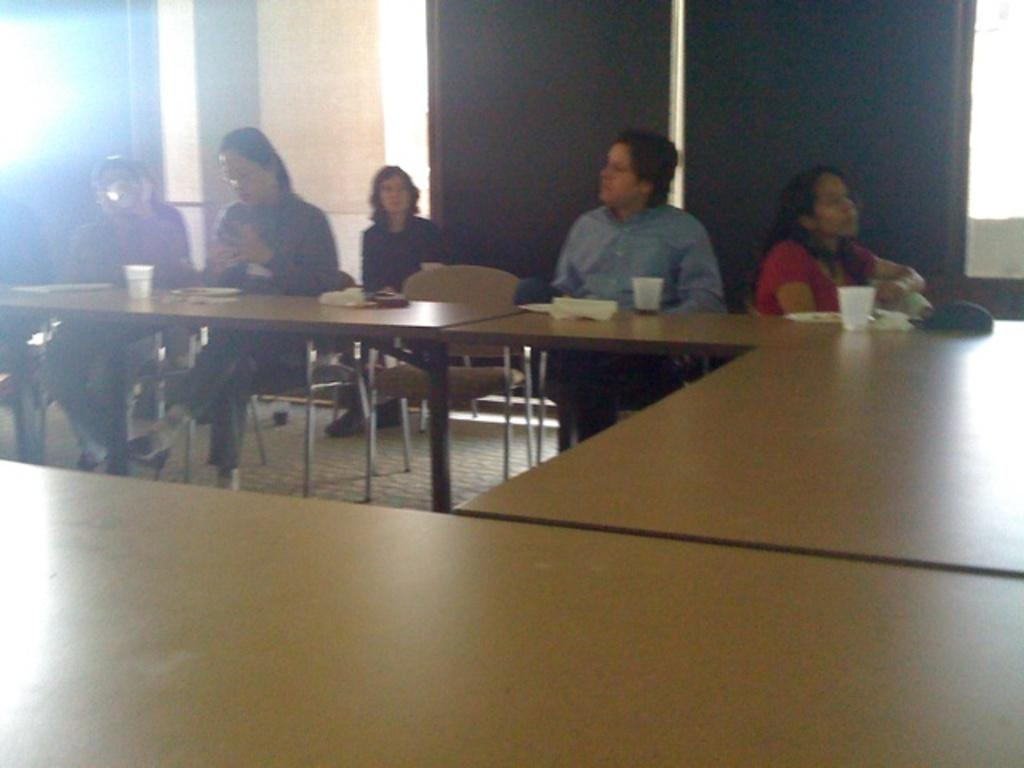How many people are present in the image? There are five people in the image. What are the people doing in the image? The people are sitting on chairs. Where are the chairs located in relation to the desk? The chairs are in front of a desk. What items can be seen on the desk? There are glasses and tissues on the desk. What type of pies are being served on the desk in the image? There are no pies present in the image; only glasses and tissues can be seen on the desk. Can you describe the position of the cat in the image? There is no cat present in the image. 